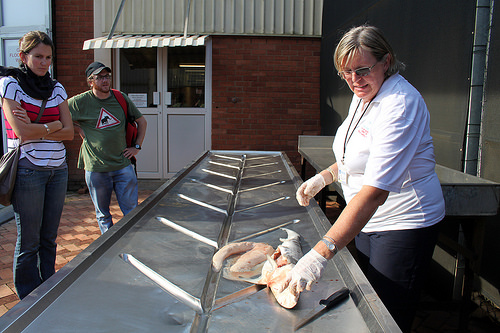<image>
Can you confirm if the woman is in front of the man? Yes. The woman is positioned in front of the man, appearing closer to the camera viewpoint. 